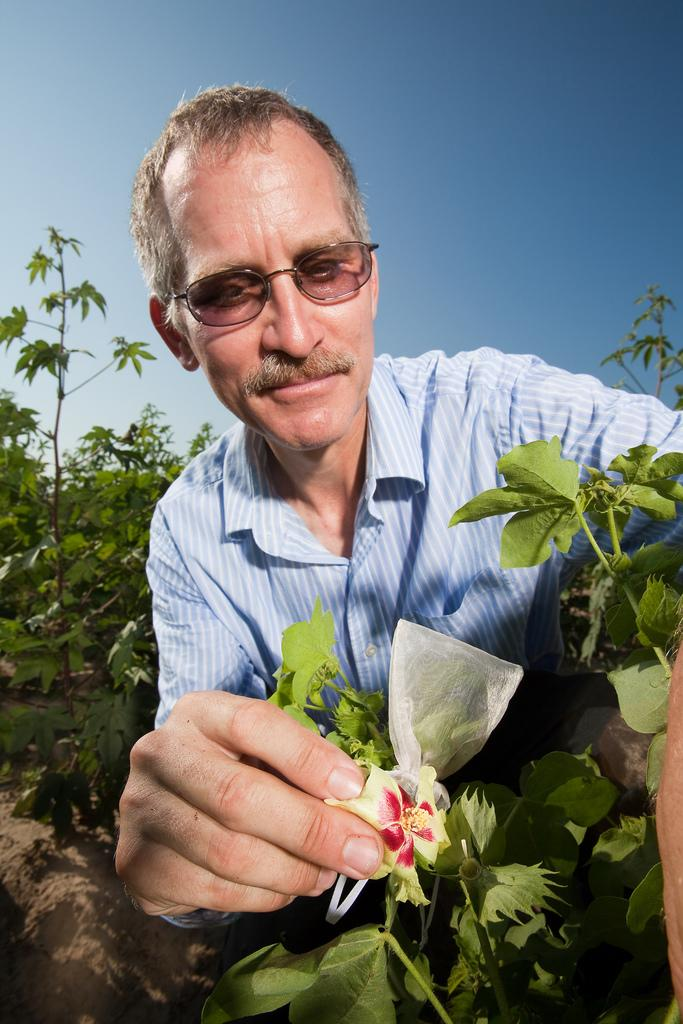Who is present in the image? There is a man in the image. What is the man wearing? The man is wearing clothes and spectacles. What can be seen in the background of the image? There are plants, sky, and soil visible in the image. Can you describe the plant in the image? There is a flower in the image. What type of key is the man holding in the image? There is no key present in the image; the man is wearing spectacles and there are plants, sky, and soil visible in the image. What is the man using to brush the plants in the image? There is no brush present in the image; the man is not interacting with the plants in any way. 